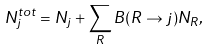<formula> <loc_0><loc_0><loc_500><loc_500>N _ { j } ^ { t o t } = N _ { j } + \sum _ { R } B ( R \rightarrow j ) N _ { R } ,</formula> 